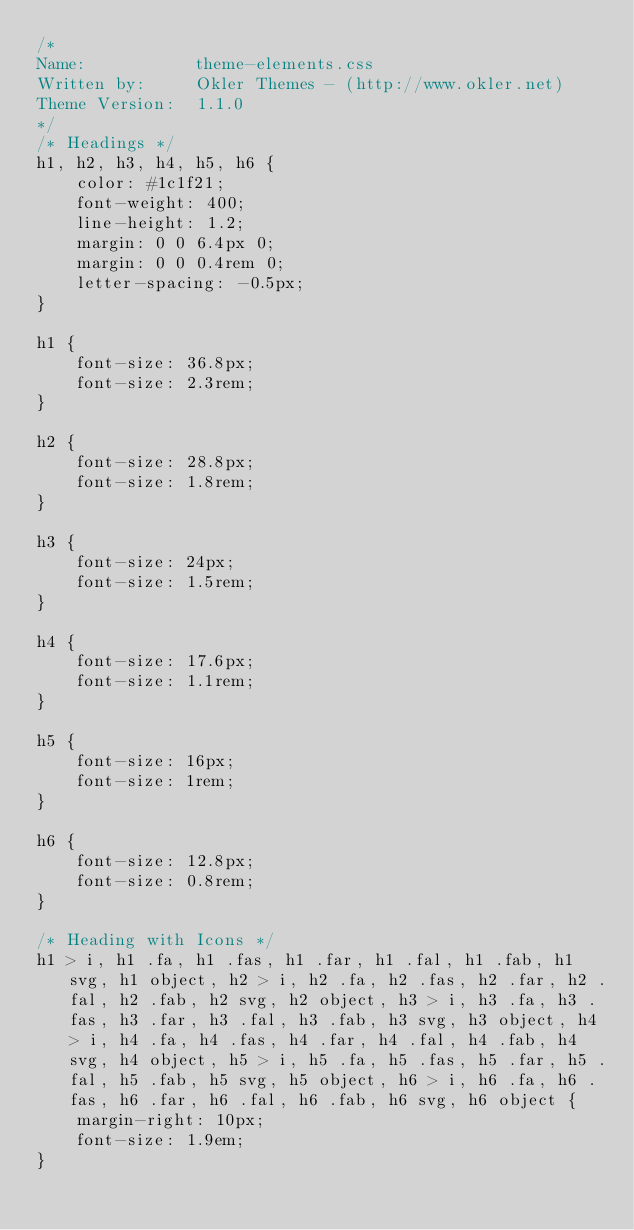Convert code to text. <code><loc_0><loc_0><loc_500><loc_500><_CSS_>/*
Name: 			theme-elements.css
Written by: 	Okler Themes - (http://www.okler.net)
Theme Version:	1.1.0
*/
/* Headings */
h1, h2, h3, h4, h5, h6 {
	color: #1c1f21;
	font-weight: 400;
	line-height: 1.2;
	margin: 0 0 6.4px 0;
	margin: 0 0 0.4rem 0;
	letter-spacing: -0.5px;
}

h1 {
	font-size: 36.8px;
	font-size: 2.3rem;
}

h2 {
	font-size: 28.8px;
	font-size: 1.8rem;
}

h3 {
	font-size: 24px;
	font-size: 1.5rem;
}

h4 {
	font-size: 17.6px;
	font-size: 1.1rem;
}

h5 {
	font-size: 16px;
	font-size: 1rem;
}

h6 {
	font-size: 12.8px;
	font-size: 0.8rem;
}

/* Heading with Icons */
h1 > i, h1 .fa, h1 .fas, h1 .far, h1 .fal, h1 .fab, h1 svg, h1 object, h2 > i, h2 .fa, h2 .fas, h2 .far, h2 .fal, h2 .fab, h2 svg, h2 object, h3 > i, h3 .fa, h3 .fas, h3 .far, h3 .fal, h3 .fab, h3 svg, h3 object, h4 > i, h4 .fa, h4 .fas, h4 .far, h4 .fal, h4 .fab, h4 svg, h4 object, h5 > i, h5 .fa, h5 .fas, h5 .far, h5 .fal, h5 .fab, h5 svg, h5 object, h6 > i, h6 .fa, h6 .fas, h6 .far, h6 .fal, h6 .fab, h6 svg, h6 object {
	margin-right: 10px;
	font-size: 1.9em;
}
</code> 